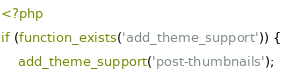Convert code to text. <code><loc_0><loc_0><loc_500><loc_500><_PHP_><?php
if (function_exists('add_theme_support')) {
    add_theme_support('post-thumbnails');</code> 